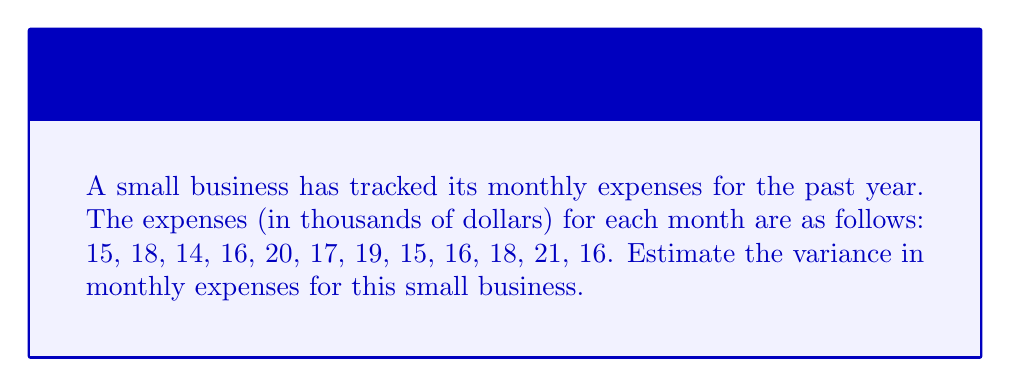Provide a solution to this math problem. To estimate the variance in monthly expenses, we'll follow these steps:

1. Calculate the mean (average) of the monthly expenses:
   $$\bar{x} = \frac{\sum_{i=1}^{n} x_i}{n}$$
   Where $x_i$ are the individual monthly expenses and $n$ is the number of months.

   $$\bar{x} = \frac{15 + 18 + 14 + 16 + 20 + 17 + 19 + 15 + 16 + 18 + 21 + 16}{12} = \frac{205}{12} = 17.0833$$

2. Calculate the squared differences from the mean:
   $$(x_i - \bar{x})^2$$
   For each month:
   $$(15 - 17.0833)^2 = 4.3403$$
   $$(18 - 17.0833)^2 = 0.8403$$
   $$(14 - 17.0833)^2 = 9.5069$$
   $$(16 - 17.0833)^2 = 1.1736$$
   $$(20 - 17.0833)^2 = 8.5069$$
   $$(17 - 17.0833)^2 = 0.0069$$
   $$(19 - 17.0833)^2 = 3.6736$$
   $$(15 - 17.0833)^2 = 4.3403$$
   $$(16 - 17.0833)^2 = 1.1736$$
   $$(18 - 17.0833)^2 = 0.8403$$
   $$(21 - 17.0833)^2 = 15.3403$$
   $$(16 - 17.0833)^2 = 1.1736$$

3. Sum the squared differences:
   $$\sum_{i=1}^{n} (x_i - \bar{x})^2 = 50.9166$$

4. Calculate the variance using the formula:
   $$s^2 = \frac{\sum_{i=1}^{n} (x_i - \bar{x})^2}{n - 1}$$

   $$s^2 = \frac{50.9166}{12 - 1} = \frac{50.9166}{11} = 4.6288$$

Therefore, the estimated variance in monthly expenses is 4.6288 (thousand dollars squared).
Answer: $4.6288$ (thousand dollars squared) 